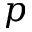Convert formula to latex. <formula><loc_0><loc_0><loc_500><loc_500>p</formula> 